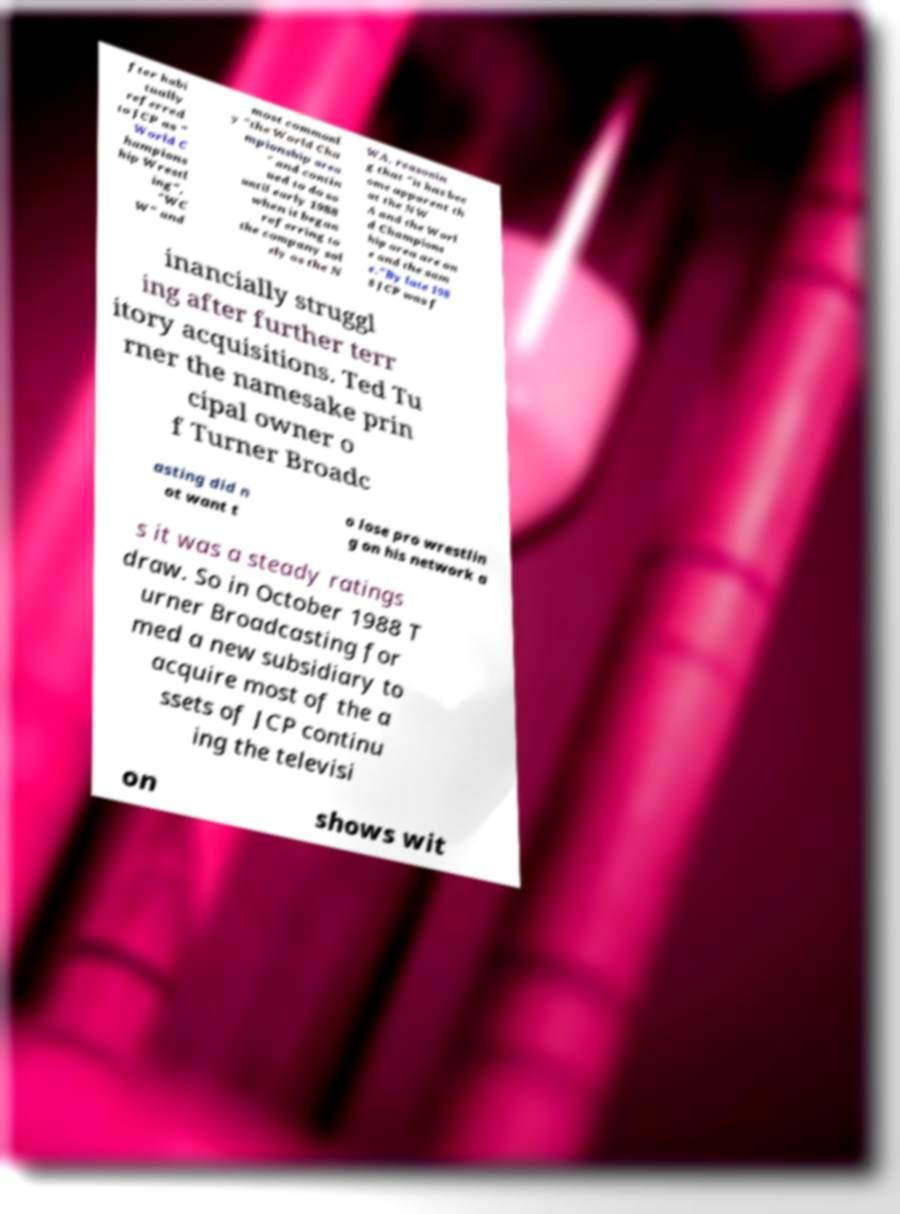Please identify and transcribe the text found in this image. fter habi tually referred to JCP as " World C hampions hip Wrestl ing", "WC W" and most commonl y "the World Cha mpionship area " and contin ued to do so until early 1988 when it began referring to the company sol ely as the N WA, reasonin g that "it has bec ome apparent th at the NW A and the Worl d Champions hip area are on e and the sam e."By late 198 8 JCP was f inancially struggl ing after further terr itory acquisitions. Ted Tu rner the namesake prin cipal owner o f Turner Broadc asting did n ot want t o lose pro wrestlin g on his network a s it was a steady ratings draw. So in October 1988 T urner Broadcasting for med a new subsidiary to acquire most of the a ssets of JCP continu ing the televisi on shows wit 